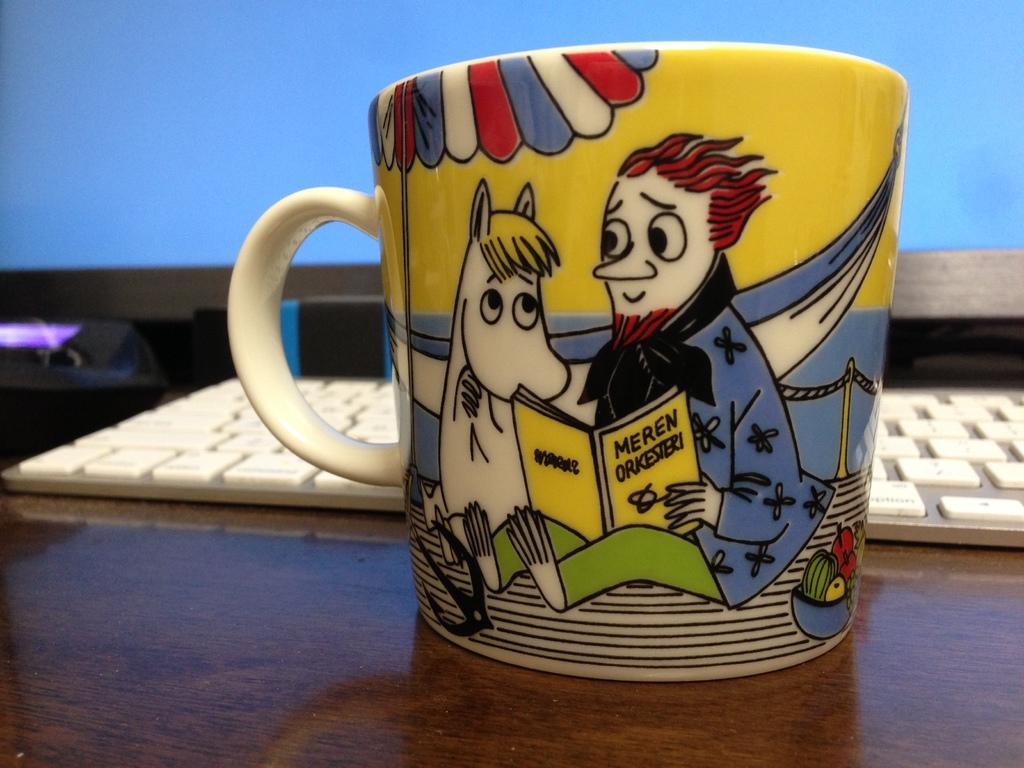<image>
Create a compact narrative representing the image presented. A yellow mug with the words "Meren Orkesteri" on it. 